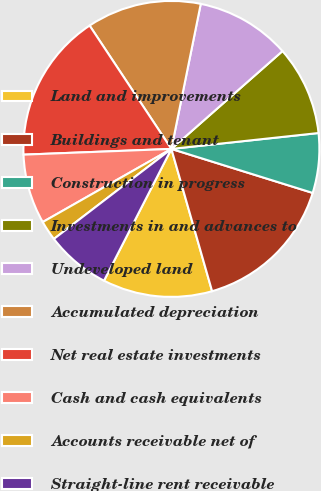Convert chart to OTSL. <chart><loc_0><loc_0><loc_500><loc_500><pie_chart><fcel>Land and improvements<fcel>Buildings and tenant<fcel>Construction in progress<fcel>Investments in and advances to<fcel>Undeveloped land<fcel>Accumulated depreciation<fcel>Net real estate investments<fcel>Cash and cash equivalents<fcel>Accounts receivable net of<fcel>Straight-line rent receivable<nl><fcel>11.96%<fcel>15.76%<fcel>6.52%<fcel>9.78%<fcel>10.33%<fcel>12.5%<fcel>16.3%<fcel>7.61%<fcel>2.18%<fcel>7.07%<nl></chart> 